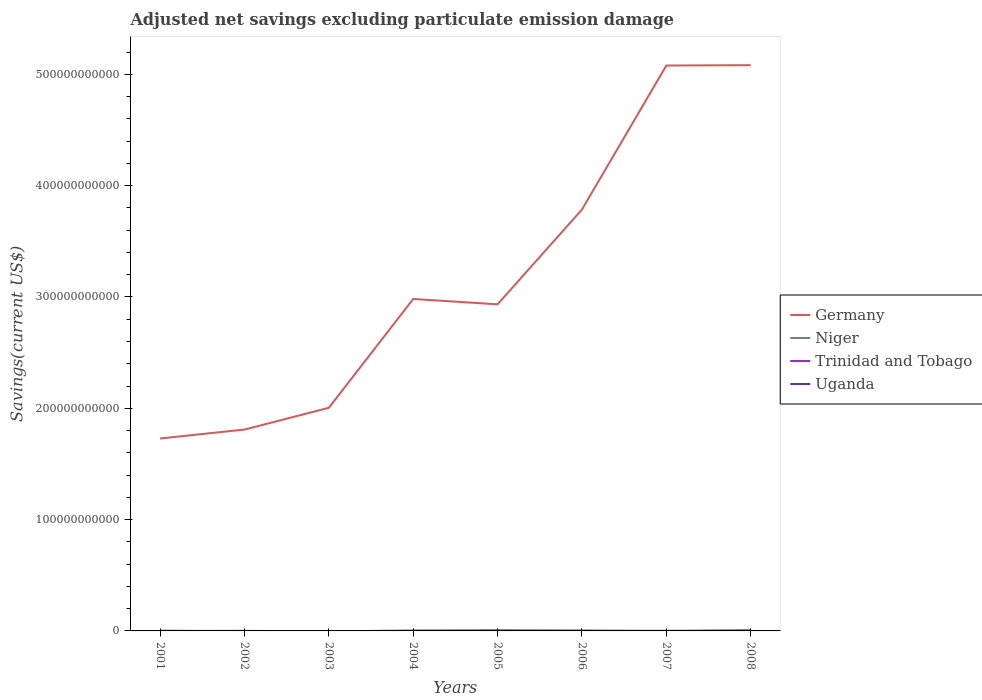Does the line corresponding to Uganda intersect with the line corresponding to Trinidad and Tobago?
Provide a succinct answer. Yes. Across all years, what is the maximum adjusted net savings in Germany?
Your answer should be compact. 1.73e+11. What is the total adjusted net savings in Germany in the graph?
Offer a terse response. -2.15e+11. What is the difference between the highest and the second highest adjusted net savings in Niger?
Ensure brevity in your answer.  4.53e+08. How many years are there in the graph?
Your response must be concise. 8. What is the difference between two consecutive major ticks on the Y-axis?
Keep it short and to the point. 1.00e+11. Are the values on the major ticks of Y-axis written in scientific E-notation?
Provide a short and direct response. No. How many legend labels are there?
Provide a short and direct response. 4. What is the title of the graph?
Your answer should be compact. Adjusted net savings excluding particulate emission damage. Does "World" appear as one of the legend labels in the graph?
Your response must be concise. No. What is the label or title of the X-axis?
Make the answer very short. Years. What is the label or title of the Y-axis?
Keep it short and to the point. Savings(current US$). What is the Savings(current US$) of Germany in 2001?
Provide a succinct answer. 1.73e+11. What is the Savings(current US$) of Niger in 2001?
Offer a terse response. 0. What is the Savings(current US$) in Trinidad and Tobago in 2001?
Your answer should be compact. 1.81e+08. What is the Savings(current US$) of Uganda in 2001?
Your answer should be compact. 1.30e+07. What is the Savings(current US$) of Germany in 2002?
Your answer should be very brief. 1.81e+11. What is the Savings(current US$) in Niger in 2002?
Offer a very short reply. 0. What is the Savings(current US$) of Uganda in 2002?
Offer a terse response. 5.33e+07. What is the Savings(current US$) in Germany in 2003?
Offer a terse response. 2.00e+11. What is the Savings(current US$) in Trinidad and Tobago in 2003?
Provide a short and direct response. 0. What is the Savings(current US$) of Uganda in 2003?
Give a very brief answer. 0. What is the Savings(current US$) of Germany in 2004?
Your answer should be very brief. 2.98e+11. What is the Savings(current US$) in Niger in 2004?
Offer a terse response. 0. What is the Savings(current US$) of Trinidad and Tobago in 2004?
Keep it short and to the point. 0. What is the Savings(current US$) in Uganda in 2004?
Give a very brief answer. 3.31e+08. What is the Savings(current US$) in Germany in 2005?
Offer a very short reply. 2.93e+11. What is the Savings(current US$) of Niger in 2005?
Your response must be concise. 1.88e+08. What is the Savings(current US$) of Trinidad and Tobago in 2005?
Your answer should be compact. 0. What is the Savings(current US$) in Uganda in 2005?
Your answer should be very brief. 4.83e+08. What is the Savings(current US$) of Germany in 2006?
Ensure brevity in your answer.  3.79e+11. What is the Savings(current US$) of Niger in 2006?
Offer a terse response. 2.29e+08. What is the Savings(current US$) in Uganda in 2006?
Ensure brevity in your answer.  2.08e+08. What is the Savings(current US$) of Germany in 2007?
Your answer should be compact. 5.08e+11. What is the Savings(current US$) of Niger in 2007?
Provide a succinct answer. 1.78e+08. What is the Savings(current US$) of Germany in 2008?
Your answer should be very brief. 5.08e+11. What is the Savings(current US$) in Niger in 2008?
Your answer should be very brief. 4.53e+08. What is the Savings(current US$) in Trinidad and Tobago in 2008?
Give a very brief answer. 0. What is the Savings(current US$) of Uganda in 2008?
Offer a terse response. 4.21e+08. Across all years, what is the maximum Savings(current US$) in Germany?
Ensure brevity in your answer.  5.08e+11. Across all years, what is the maximum Savings(current US$) of Niger?
Offer a very short reply. 4.53e+08. Across all years, what is the maximum Savings(current US$) of Trinidad and Tobago?
Make the answer very short. 1.81e+08. Across all years, what is the maximum Savings(current US$) in Uganda?
Ensure brevity in your answer.  4.83e+08. Across all years, what is the minimum Savings(current US$) of Germany?
Provide a short and direct response. 1.73e+11. Across all years, what is the minimum Savings(current US$) in Uganda?
Provide a succinct answer. 0. What is the total Savings(current US$) in Germany in the graph?
Your answer should be very brief. 2.54e+12. What is the total Savings(current US$) of Niger in the graph?
Give a very brief answer. 1.05e+09. What is the total Savings(current US$) of Trinidad and Tobago in the graph?
Offer a very short reply. 1.81e+08. What is the total Savings(current US$) in Uganda in the graph?
Ensure brevity in your answer.  1.51e+09. What is the difference between the Savings(current US$) in Germany in 2001 and that in 2002?
Provide a short and direct response. -8.03e+09. What is the difference between the Savings(current US$) in Uganda in 2001 and that in 2002?
Make the answer very short. -4.04e+07. What is the difference between the Savings(current US$) of Germany in 2001 and that in 2003?
Offer a very short reply. -2.76e+1. What is the difference between the Savings(current US$) of Germany in 2001 and that in 2004?
Your answer should be compact. -1.25e+11. What is the difference between the Savings(current US$) of Uganda in 2001 and that in 2004?
Keep it short and to the point. -3.18e+08. What is the difference between the Savings(current US$) in Germany in 2001 and that in 2005?
Provide a succinct answer. -1.21e+11. What is the difference between the Savings(current US$) of Uganda in 2001 and that in 2005?
Your answer should be compact. -4.70e+08. What is the difference between the Savings(current US$) in Germany in 2001 and that in 2006?
Keep it short and to the point. -2.06e+11. What is the difference between the Savings(current US$) of Uganda in 2001 and that in 2006?
Provide a succinct answer. -1.95e+08. What is the difference between the Savings(current US$) of Germany in 2001 and that in 2007?
Provide a short and direct response. -3.35e+11. What is the difference between the Savings(current US$) in Germany in 2001 and that in 2008?
Your response must be concise. -3.35e+11. What is the difference between the Savings(current US$) of Uganda in 2001 and that in 2008?
Give a very brief answer. -4.08e+08. What is the difference between the Savings(current US$) of Germany in 2002 and that in 2003?
Give a very brief answer. -1.95e+1. What is the difference between the Savings(current US$) in Germany in 2002 and that in 2004?
Provide a succinct answer. -1.17e+11. What is the difference between the Savings(current US$) of Uganda in 2002 and that in 2004?
Offer a terse response. -2.77e+08. What is the difference between the Savings(current US$) of Germany in 2002 and that in 2005?
Your answer should be very brief. -1.13e+11. What is the difference between the Savings(current US$) in Uganda in 2002 and that in 2005?
Make the answer very short. -4.30e+08. What is the difference between the Savings(current US$) in Germany in 2002 and that in 2006?
Your answer should be very brief. -1.98e+11. What is the difference between the Savings(current US$) in Uganda in 2002 and that in 2006?
Your answer should be very brief. -1.54e+08. What is the difference between the Savings(current US$) in Germany in 2002 and that in 2007?
Make the answer very short. -3.27e+11. What is the difference between the Savings(current US$) of Germany in 2002 and that in 2008?
Your answer should be compact. -3.27e+11. What is the difference between the Savings(current US$) in Uganda in 2002 and that in 2008?
Your answer should be compact. -3.67e+08. What is the difference between the Savings(current US$) in Germany in 2003 and that in 2004?
Your response must be concise. -9.78e+1. What is the difference between the Savings(current US$) of Germany in 2003 and that in 2005?
Your answer should be very brief. -9.30e+1. What is the difference between the Savings(current US$) of Germany in 2003 and that in 2006?
Provide a short and direct response. -1.78e+11. What is the difference between the Savings(current US$) of Germany in 2003 and that in 2007?
Ensure brevity in your answer.  -3.08e+11. What is the difference between the Savings(current US$) of Germany in 2003 and that in 2008?
Ensure brevity in your answer.  -3.08e+11. What is the difference between the Savings(current US$) in Germany in 2004 and that in 2005?
Provide a succinct answer. 4.80e+09. What is the difference between the Savings(current US$) in Uganda in 2004 and that in 2005?
Offer a terse response. -1.53e+08. What is the difference between the Savings(current US$) of Germany in 2004 and that in 2006?
Offer a terse response. -8.03e+1. What is the difference between the Savings(current US$) in Uganda in 2004 and that in 2006?
Provide a succinct answer. 1.23e+08. What is the difference between the Savings(current US$) in Germany in 2004 and that in 2007?
Ensure brevity in your answer.  -2.10e+11. What is the difference between the Savings(current US$) in Germany in 2004 and that in 2008?
Your answer should be compact. -2.10e+11. What is the difference between the Savings(current US$) in Uganda in 2004 and that in 2008?
Your answer should be very brief. -9.02e+07. What is the difference between the Savings(current US$) in Germany in 2005 and that in 2006?
Provide a short and direct response. -8.51e+1. What is the difference between the Savings(current US$) of Niger in 2005 and that in 2006?
Your response must be concise. -4.12e+07. What is the difference between the Savings(current US$) of Uganda in 2005 and that in 2006?
Offer a terse response. 2.75e+08. What is the difference between the Savings(current US$) in Germany in 2005 and that in 2007?
Offer a very short reply. -2.15e+11. What is the difference between the Savings(current US$) in Niger in 2005 and that in 2007?
Provide a short and direct response. 1.00e+07. What is the difference between the Savings(current US$) of Germany in 2005 and that in 2008?
Provide a short and direct response. -2.15e+11. What is the difference between the Savings(current US$) of Niger in 2005 and that in 2008?
Your response must be concise. -2.65e+08. What is the difference between the Savings(current US$) in Uganda in 2005 and that in 2008?
Ensure brevity in your answer.  6.23e+07. What is the difference between the Savings(current US$) of Germany in 2006 and that in 2007?
Offer a terse response. -1.29e+11. What is the difference between the Savings(current US$) in Niger in 2006 and that in 2007?
Make the answer very short. 5.12e+07. What is the difference between the Savings(current US$) of Germany in 2006 and that in 2008?
Make the answer very short. -1.30e+11. What is the difference between the Savings(current US$) of Niger in 2006 and that in 2008?
Offer a terse response. -2.24e+08. What is the difference between the Savings(current US$) in Uganda in 2006 and that in 2008?
Make the answer very short. -2.13e+08. What is the difference between the Savings(current US$) in Germany in 2007 and that in 2008?
Your answer should be compact. -2.97e+08. What is the difference between the Savings(current US$) of Niger in 2007 and that in 2008?
Offer a terse response. -2.75e+08. What is the difference between the Savings(current US$) in Germany in 2001 and the Savings(current US$) in Uganda in 2002?
Make the answer very short. 1.73e+11. What is the difference between the Savings(current US$) of Trinidad and Tobago in 2001 and the Savings(current US$) of Uganda in 2002?
Your answer should be very brief. 1.28e+08. What is the difference between the Savings(current US$) in Germany in 2001 and the Savings(current US$) in Uganda in 2004?
Ensure brevity in your answer.  1.73e+11. What is the difference between the Savings(current US$) of Trinidad and Tobago in 2001 and the Savings(current US$) of Uganda in 2004?
Offer a terse response. -1.49e+08. What is the difference between the Savings(current US$) of Germany in 2001 and the Savings(current US$) of Niger in 2005?
Provide a short and direct response. 1.73e+11. What is the difference between the Savings(current US$) in Germany in 2001 and the Savings(current US$) in Uganda in 2005?
Offer a very short reply. 1.72e+11. What is the difference between the Savings(current US$) in Trinidad and Tobago in 2001 and the Savings(current US$) in Uganda in 2005?
Provide a short and direct response. -3.02e+08. What is the difference between the Savings(current US$) in Germany in 2001 and the Savings(current US$) in Niger in 2006?
Offer a very short reply. 1.73e+11. What is the difference between the Savings(current US$) of Germany in 2001 and the Savings(current US$) of Uganda in 2006?
Provide a short and direct response. 1.73e+11. What is the difference between the Savings(current US$) of Trinidad and Tobago in 2001 and the Savings(current US$) of Uganda in 2006?
Your answer should be compact. -2.62e+07. What is the difference between the Savings(current US$) in Germany in 2001 and the Savings(current US$) in Niger in 2007?
Your response must be concise. 1.73e+11. What is the difference between the Savings(current US$) of Germany in 2001 and the Savings(current US$) of Niger in 2008?
Give a very brief answer. 1.72e+11. What is the difference between the Savings(current US$) of Germany in 2001 and the Savings(current US$) of Uganda in 2008?
Keep it short and to the point. 1.72e+11. What is the difference between the Savings(current US$) in Trinidad and Tobago in 2001 and the Savings(current US$) in Uganda in 2008?
Offer a very short reply. -2.39e+08. What is the difference between the Savings(current US$) in Germany in 2002 and the Savings(current US$) in Uganda in 2004?
Ensure brevity in your answer.  1.81e+11. What is the difference between the Savings(current US$) of Germany in 2002 and the Savings(current US$) of Niger in 2005?
Your answer should be very brief. 1.81e+11. What is the difference between the Savings(current US$) in Germany in 2002 and the Savings(current US$) in Uganda in 2005?
Offer a very short reply. 1.80e+11. What is the difference between the Savings(current US$) in Germany in 2002 and the Savings(current US$) in Niger in 2006?
Provide a short and direct response. 1.81e+11. What is the difference between the Savings(current US$) in Germany in 2002 and the Savings(current US$) in Uganda in 2006?
Keep it short and to the point. 1.81e+11. What is the difference between the Savings(current US$) of Germany in 2002 and the Savings(current US$) of Niger in 2007?
Ensure brevity in your answer.  1.81e+11. What is the difference between the Savings(current US$) of Germany in 2002 and the Savings(current US$) of Niger in 2008?
Provide a short and direct response. 1.80e+11. What is the difference between the Savings(current US$) of Germany in 2002 and the Savings(current US$) of Uganda in 2008?
Keep it short and to the point. 1.80e+11. What is the difference between the Savings(current US$) in Germany in 2003 and the Savings(current US$) in Uganda in 2004?
Your response must be concise. 2.00e+11. What is the difference between the Savings(current US$) of Germany in 2003 and the Savings(current US$) of Niger in 2005?
Give a very brief answer. 2.00e+11. What is the difference between the Savings(current US$) in Germany in 2003 and the Savings(current US$) in Uganda in 2005?
Your response must be concise. 2.00e+11. What is the difference between the Savings(current US$) in Germany in 2003 and the Savings(current US$) in Niger in 2006?
Your answer should be compact. 2.00e+11. What is the difference between the Savings(current US$) of Germany in 2003 and the Savings(current US$) of Uganda in 2006?
Make the answer very short. 2.00e+11. What is the difference between the Savings(current US$) of Germany in 2003 and the Savings(current US$) of Niger in 2007?
Make the answer very short. 2.00e+11. What is the difference between the Savings(current US$) of Germany in 2003 and the Savings(current US$) of Niger in 2008?
Make the answer very short. 2.00e+11. What is the difference between the Savings(current US$) of Germany in 2003 and the Savings(current US$) of Uganda in 2008?
Your response must be concise. 2.00e+11. What is the difference between the Savings(current US$) of Germany in 2004 and the Savings(current US$) of Niger in 2005?
Your response must be concise. 2.98e+11. What is the difference between the Savings(current US$) in Germany in 2004 and the Savings(current US$) in Uganda in 2005?
Make the answer very short. 2.98e+11. What is the difference between the Savings(current US$) in Germany in 2004 and the Savings(current US$) in Niger in 2006?
Keep it short and to the point. 2.98e+11. What is the difference between the Savings(current US$) of Germany in 2004 and the Savings(current US$) of Uganda in 2006?
Make the answer very short. 2.98e+11. What is the difference between the Savings(current US$) in Germany in 2004 and the Savings(current US$) in Niger in 2007?
Keep it short and to the point. 2.98e+11. What is the difference between the Savings(current US$) in Germany in 2004 and the Savings(current US$) in Niger in 2008?
Provide a short and direct response. 2.98e+11. What is the difference between the Savings(current US$) of Germany in 2004 and the Savings(current US$) of Uganda in 2008?
Offer a very short reply. 2.98e+11. What is the difference between the Savings(current US$) of Germany in 2005 and the Savings(current US$) of Niger in 2006?
Offer a terse response. 2.93e+11. What is the difference between the Savings(current US$) of Germany in 2005 and the Savings(current US$) of Uganda in 2006?
Make the answer very short. 2.93e+11. What is the difference between the Savings(current US$) of Niger in 2005 and the Savings(current US$) of Uganda in 2006?
Provide a short and direct response. -1.98e+07. What is the difference between the Savings(current US$) in Germany in 2005 and the Savings(current US$) in Niger in 2007?
Ensure brevity in your answer.  2.93e+11. What is the difference between the Savings(current US$) in Germany in 2005 and the Savings(current US$) in Niger in 2008?
Ensure brevity in your answer.  2.93e+11. What is the difference between the Savings(current US$) in Germany in 2005 and the Savings(current US$) in Uganda in 2008?
Provide a short and direct response. 2.93e+11. What is the difference between the Savings(current US$) in Niger in 2005 and the Savings(current US$) in Uganda in 2008?
Provide a short and direct response. -2.33e+08. What is the difference between the Savings(current US$) in Germany in 2006 and the Savings(current US$) in Niger in 2007?
Your answer should be very brief. 3.78e+11. What is the difference between the Savings(current US$) of Germany in 2006 and the Savings(current US$) of Niger in 2008?
Offer a terse response. 3.78e+11. What is the difference between the Savings(current US$) in Germany in 2006 and the Savings(current US$) in Uganda in 2008?
Offer a terse response. 3.78e+11. What is the difference between the Savings(current US$) of Niger in 2006 and the Savings(current US$) of Uganda in 2008?
Offer a very short reply. -1.92e+08. What is the difference between the Savings(current US$) of Germany in 2007 and the Savings(current US$) of Niger in 2008?
Make the answer very short. 5.08e+11. What is the difference between the Savings(current US$) of Germany in 2007 and the Savings(current US$) of Uganda in 2008?
Make the answer very short. 5.08e+11. What is the difference between the Savings(current US$) in Niger in 2007 and the Savings(current US$) in Uganda in 2008?
Make the answer very short. -2.43e+08. What is the average Savings(current US$) in Germany per year?
Provide a short and direct response. 3.18e+11. What is the average Savings(current US$) in Niger per year?
Provide a short and direct response. 1.31e+08. What is the average Savings(current US$) of Trinidad and Tobago per year?
Provide a succinct answer. 2.27e+07. What is the average Savings(current US$) of Uganda per year?
Provide a succinct answer. 1.89e+08. In the year 2001, what is the difference between the Savings(current US$) of Germany and Savings(current US$) of Trinidad and Tobago?
Keep it short and to the point. 1.73e+11. In the year 2001, what is the difference between the Savings(current US$) in Germany and Savings(current US$) in Uganda?
Provide a succinct answer. 1.73e+11. In the year 2001, what is the difference between the Savings(current US$) in Trinidad and Tobago and Savings(current US$) in Uganda?
Your answer should be compact. 1.68e+08. In the year 2002, what is the difference between the Savings(current US$) of Germany and Savings(current US$) of Uganda?
Make the answer very short. 1.81e+11. In the year 2004, what is the difference between the Savings(current US$) of Germany and Savings(current US$) of Uganda?
Give a very brief answer. 2.98e+11. In the year 2005, what is the difference between the Savings(current US$) of Germany and Savings(current US$) of Niger?
Offer a very short reply. 2.93e+11. In the year 2005, what is the difference between the Savings(current US$) in Germany and Savings(current US$) in Uganda?
Your answer should be very brief. 2.93e+11. In the year 2005, what is the difference between the Savings(current US$) in Niger and Savings(current US$) in Uganda?
Offer a very short reply. -2.95e+08. In the year 2006, what is the difference between the Savings(current US$) of Germany and Savings(current US$) of Niger?
Offer a terse response. 3.78e+11. In the year 2006, what is the difference between the Savings(current US$) in Germany and Savings(current US$) in Uganda?
Make the answer very short. 3.78e+11. In the year 2006, what is the difference between the Savings(current US$) of Niger and Savings(current US$) of Uganda?
Keep it short and to the point. 2.14e+07. In the year 2007, what is the difference between the Savings(current US$) in Germany and Savings(current US$) in Niger?
Make the answer very short. 5.08e+11. In the year 2008, what is the difference between the Savings(current US$) in Germany and Savings(current US$) in Niger?
Ensure brevity in your answer.  5.08e+11. In the year 2008, what is the difference between the Savings(current US$) in Germany and Savings(current US$) in Uganda?
Your answer should be very brief. 5.08e+11. In the year 2008, what is the difference between the Savings(current US$) of Niger and Savings(current US$) of Uganda?
Your answer should be compact. 3.22e+07. What is the ratio of the Savings(current US$) of Germany in 2001 to that in 2002?
Offer a terse response. 0.96. What is the ratio of the Savings(current US$) of Uganda in 2001 to that in 2002?
Your answer should be compact. 0.24. What is the ratio of the Savings(current US$) in Germany in 2001 to that in 2003?
Make the answer very short. 0.86. What is the ratio of the Savings(current US$) in Germany in 2001 to that in 2004?
Your answer should be compact. 0.58. What is the ratio of the Savings(current US$) of Uganda in 2001 to that in 2004?
Make the answer very short. 0.04. What is the ratio of the Savings(current US$) in Germany in 2001 to that in 2005?
Your answer should be compact. 0.59. What is the ratio of the Savings(current US$) in Uganda in 2001 to that in 2005?
Provide a succinct answer. 0.03. What is the ratio of the Savings(current US$) in Germany in 2001 to that in 2006?
Provide a succinct answer. 0.46. What is the ratio of the Savings(current US$) of Uganda in 2001 to that in 2006?
Make the answer very short. 0.06. What is the ratio of the Savings(current US$) of Germany in 2001 to that in 2007?
Provide a succinct answer. 0.34. What is the ratio of the Savings(current US$) in Germany in 2001 to that in 2008?
Your response must be concise. 0.34. What is the ratio of the Savings(current US$) of Uganda in 2001 to that in 2008?
Provide a succinct answer. 0.03. What is the ratio of the Savings(current US$) in Germany in 2002 to that in 2003?
Provide a succinct answer. 0.9. What is the ratio of the Savings(current US$) of Germany in 2002 to that in 2004?
Your response must be concise. 0.61. What is the ratio of the Savings(current US$) of Uganda in 2002 to that in 2004?
Provide a short and direct response. 0.16. What is the ratio of the Savings(current US$) in Germany in 2002 to that in 2005?
Your answer should be very brief. 0.62. What is the ratio of the Savings(current US$) in Uganda in 2002 to that in 2005?
Give a very brief answer. 0.11. What is the ratio of the Savings(current US$) of Germany in 2002 to that in 2006?
Provide a short and direct response. 0.48. What is the ratio of the Savings(current US$) of Uganda in 2002 to that in 2006?
Offer a very short reply. 0.26. What is the ratio of the Savings(current US$) of Germany in 2002 to that in 2007?
Offer a terse response. 0.36. What is the ratio of the Savings(current US$) in Germany in 2002 to that in 2008?
Provide a succinct answer. 0.36. What is the ratio of the Savings(current US$) of Uganda in 2002 to that in 2008?
Keep it short and to the point. 0.13. What is the ratio of the Savings(current US$) of Germany in 2003 to that in 2004?
Make the answer very short. 0.67. What is the ratio of the Savings(current US$) of Germany in 2003 to that in 2005?
Provide a short and direct response. 0.68. What is the ratio of the Savings(current US$) in Germany in 2003 to that in 2006?
Keep it short and to the point. 0.53. What is the ratio of the Savings(current US$) of Germany in 2003 to that in 2007?
Ensure brevity in your answer.  0.39. What is the ratio of the Savings(current US$) in Germany in 2003 to that in 2008?
Your answer should be compact. 0.39. What is the ratio of the Savings(current US$) in Germany in 2004 to that in 2005?
Offer a very short reply. 1.02. What is the ratio of the Savings(current US$) in Uganda in 2004 to that in 2005?
Give a very brief answer. 0.68. What is the ratio of the Savings(current US$) of Germany in 2004 to that in 2006?
Your answer should be very brief. 0.79. What is the ratio of the Savings(current US$) in Uganda in 2004 to that in 2006?
Make the answer very short. 1.59. What is the ratio of the Savings(current US$) in Germany in 2004 to that in 2007?
Make the answer very short. 0.59. What is the ratio of the Savings(current US$) of Germany in 2004 to that in 2008?
Provide a succinct answer. 0.59. What is the ratio of the Savings(current US$) in Uganda in 2004 to that in 2008?
Ensure brevity in your answer.  0.79. What is the ratio of the Savings(current US$) in Germany in 2005 to that in 2006?
Make the answer very short. 0.78. What is the ratio of the Savings(current US$) in Niger in 2005 to that in 2006?
Offer a very short reply. 0.82. What is the ratio of the Savings(current US$) in Uganda in 2005 to that in 2006?
Your answer should be compact. 2.33. What is the ratio of the Savings(current US$) of Germany in 2005 to that in 2007?
Ensure brevity in your answer.  0.58. What is the ratio of the Savings(current US$) of Niger in 2005 to that in 2007?
Offer a very short reply. 1.06. What is the ratio of the Savings(current US$) in Germany in 2005 to that in 2008?
Provide a succinct answer. 0.58. What is the ratio of the Savings(current US$) in Niger in 2005 to that in 2008?
Make the answer very short. 0.41. What is the ratio of the Savings(current US$) in Uganda in 2005 to that in 2008?
Provide a succinct answer. 1.15. What is the ratio of the Savings(current US$) in Germany in 2006 to that in 2007?
Provide a short and direct response. 0.75. What is the ratio of the Savings(current US$) in Niger in 2006 to that in 2007?
Offer a very short reply. 1.29. What is the ratio of the Savings(current US$) in Germany in 2006 to that in 2008?
Give a very brief answer. 0.74. What is the ratio of the Savings(current US$) of Niger in 2006 to that in 2008?
Your response must be concise. 0.51. What is the ratio of the Savings(current US$) in Uganda in 2006 to that in 2008?
Ensure brevity in your answer.  0.49. What is the ratio of the Savings(current US$) in Germany in 2007 to that in 2008?
Provide a short and direct response. 1. What is the ratio of the Savings(current US$) of Niger in 2007 to that in 2008?
Your response must be concise. 0.39. What is the difference between the highest and the second highest Savings(current US$) of Germany?
Ensure brevity in your answer.  2.97e+08. What is the difference between the highest and the second highest Savings(current US$) of Niger?
Your response must be concise. 2.24e+08. What is the difference between the highest and the second highest Savings(current US$) in Uganda?
Offer a terse response. 6.23e+07. What is the difference between the highest and the lowest Savings(current US$) in Germany?
Give a very brief answer. 3.35e+11. What is the difference between the highest and the lowest Savings(current US$) in Niger?
Make the answer very short. 4.53e+08. What is the difference between the highest and the lowest Savings(current US$) of Trinidad and Tobago?
Provide a succinct answer. 1.81e+08. What is the difference between the highest and the lowest Savings(current US$) in Uganda?
Provide a succinct answer. 4.83e+08. 